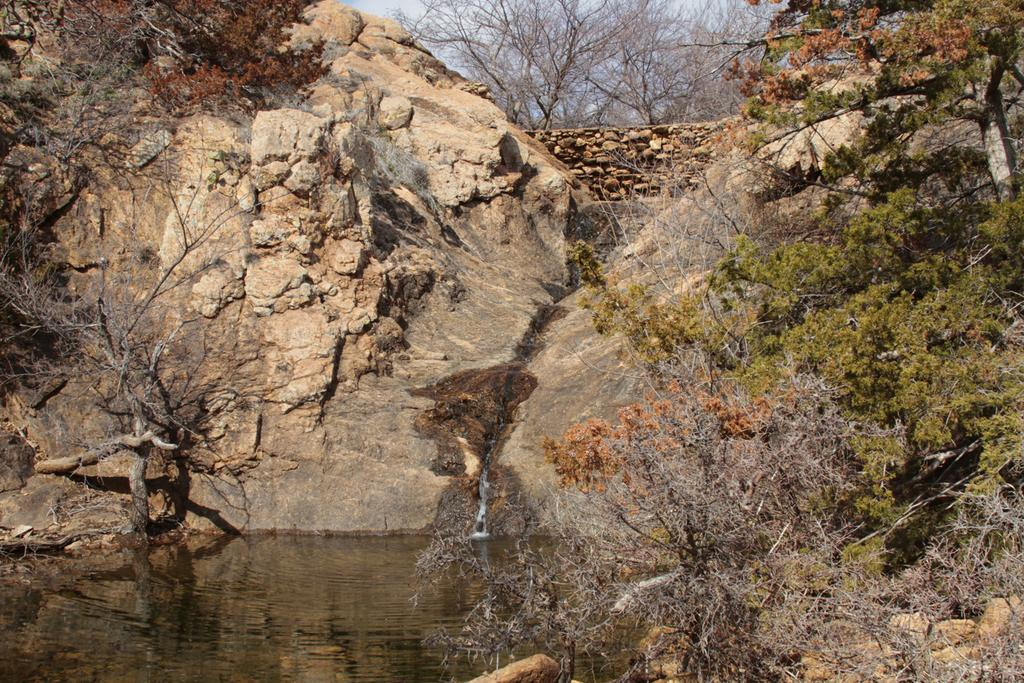What is the primary element visible in the image? There is a water surface in the image. What type of vegetation can be seen in the image? There are trees in the image. What can be seen in the background of the image? There are rocks and the sky visible in the background of the image. What type of disgust can be seen on the rocks in the image? There is no indication of disgust in the image, and rocks do not have the ability to express emotions. 